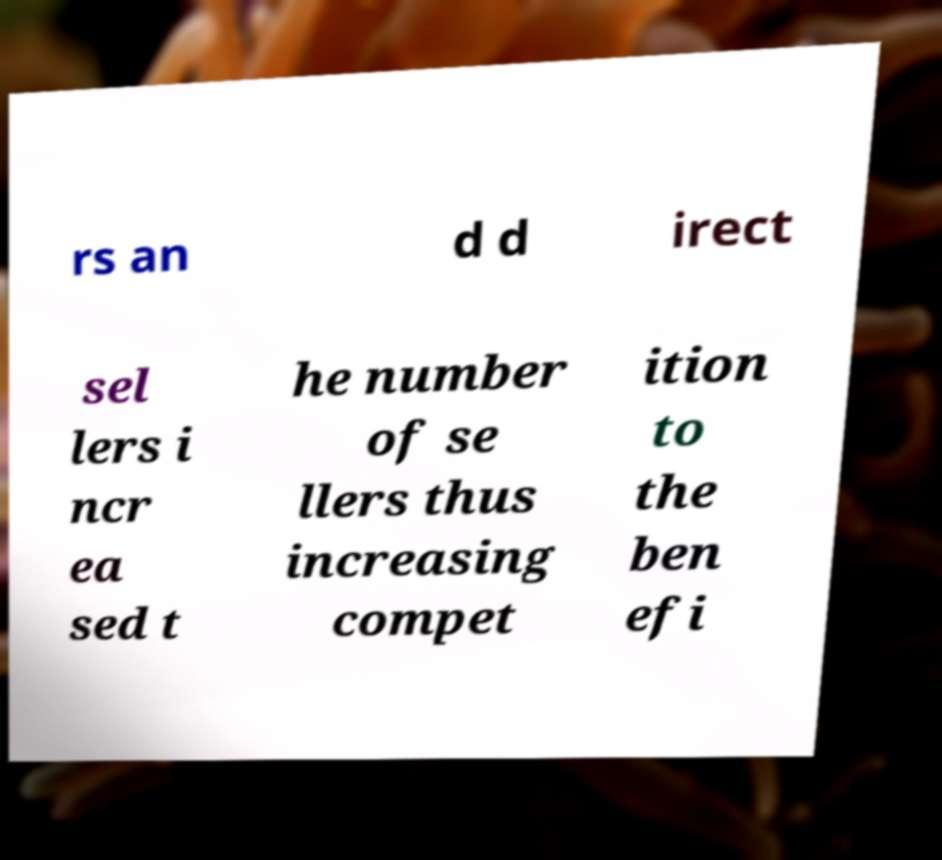Can you read and provide the text displayed in the image?This photo seems to have some interesting text. Can you extract and type it out for me? rs an d d irect sel lers i ncr ea sed t he number of se llers thus increasing compet ition to the ben efi 